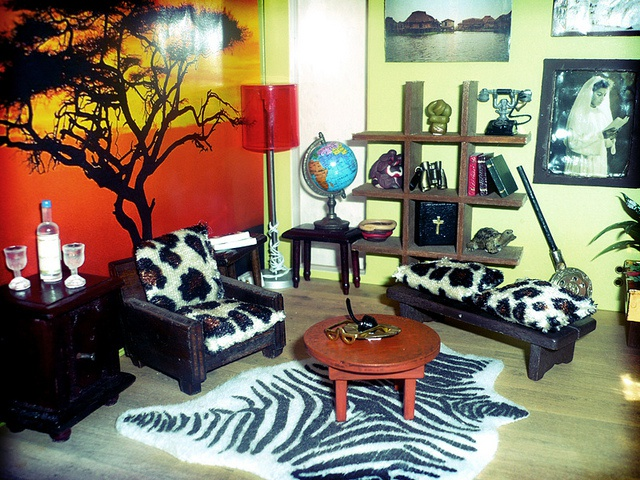Describe the objects in this image and their specific colors. I can see couch in maroon, black, beige, and gray tones, chair in maroon, black, beige, and gray tones, couch in maroon, black, ivory, and gray tones, book in maroon, gray, black, teal, and navy tones, and book in maroon, black, navy, purple, and blue tones in this image. 